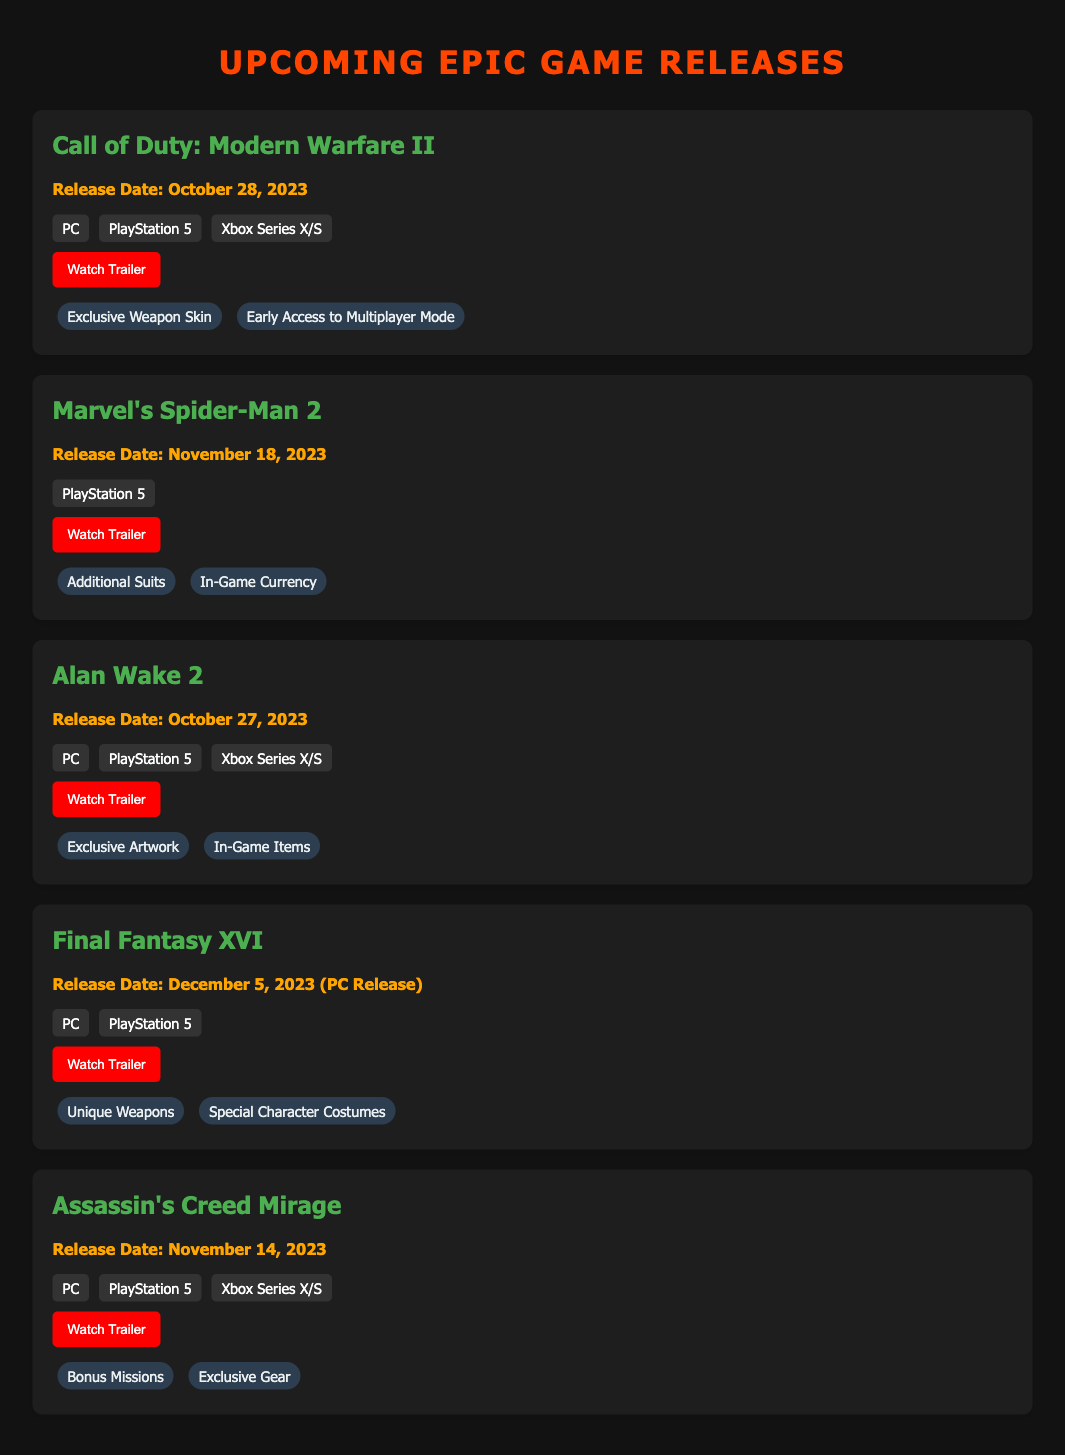What is the release date for Call of Duty: Modern Warfare II? The release date for Call of Duty: Modern Warfare II is stated in the document as October 28, 2023.
Answer: October 28, 2023 Which platforms will Alan Wake 2 be available on? The platforms for Alan Wake 2 are listed in the document, which include PC, PlayStation 5, and Xbox Series X/S.
Answer: PC, PlayStation 5, Xbox Series X/S What pre-order bonus is offered for Marvel's Spider-Man 2? The document mentions that Marvel's Spider-Man 2 includes additional suits and in-game currency as pre-order bonuses.
Answer: Additional Suits, In-Game Currency How many games have a release date in November 2023? By reviewing the document, it is noted that there are three games with a release date in November 2023: Marvel's Spider-Man 2, Assassin's Creed Mirage, and a specific date for their releases.
Answer: 3 What is the trailer link for Final Fantasy XVI? The document provides a trailer link for Final Fantasy XVI, which can be found in the pre-order section of the game.
Answer: https://www.youtube.com/watch?v=ghi012 